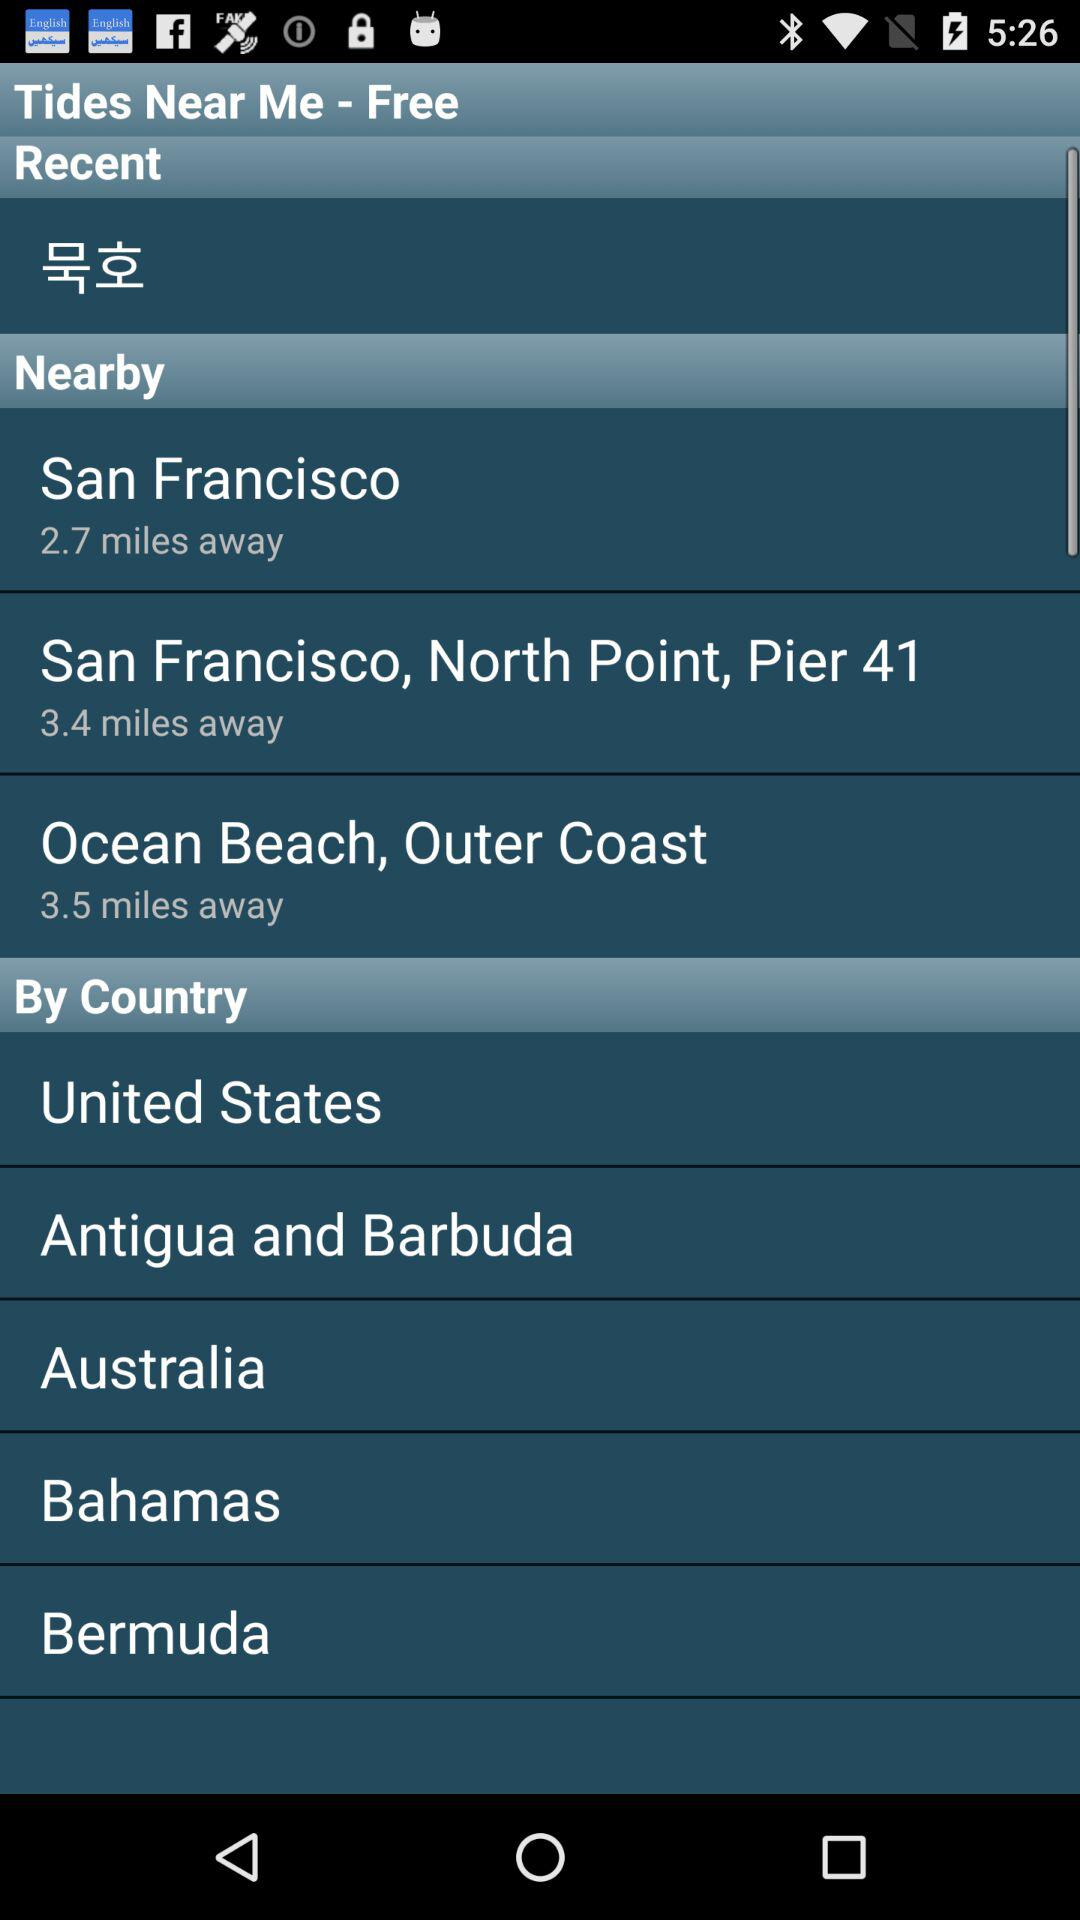How many miles away is San Francisco? San Francisco is 2.7 miles away. 